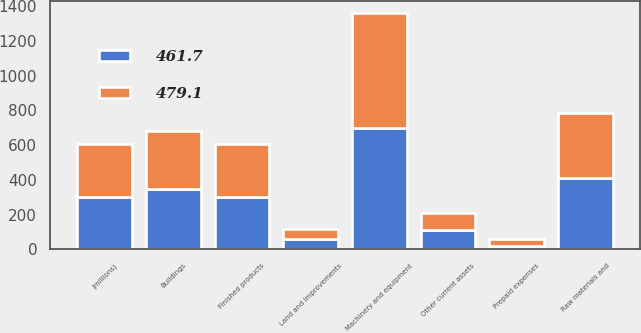Convert chart to OTSL. <chart><loc_0><loc_0><loc_500><loc_500><stacked_bar_chart><ecel><fcel>(millions)<fcel>Finished products<fcel>Raw materials and<fcel>Prepaid expenses<fcel>Other current assets<fcel>Land and improvements<fcel>Buildings<fcel>Machinery and equipment<nl><fcel>461.7<fcel>303.9<fcel>303.2<fcel>410.6<fcel>20.3<fcel>111.2<fcel>57.6<fcel>346.4<fcel>700.7<nl><fcel>479.1<fcel>303.9<fcel>304.6<fcel>372.3<fcel>37.7<fcel>97.1<fcel>59.3<fcel>335.4<fcel>661.3<nl></chart> 